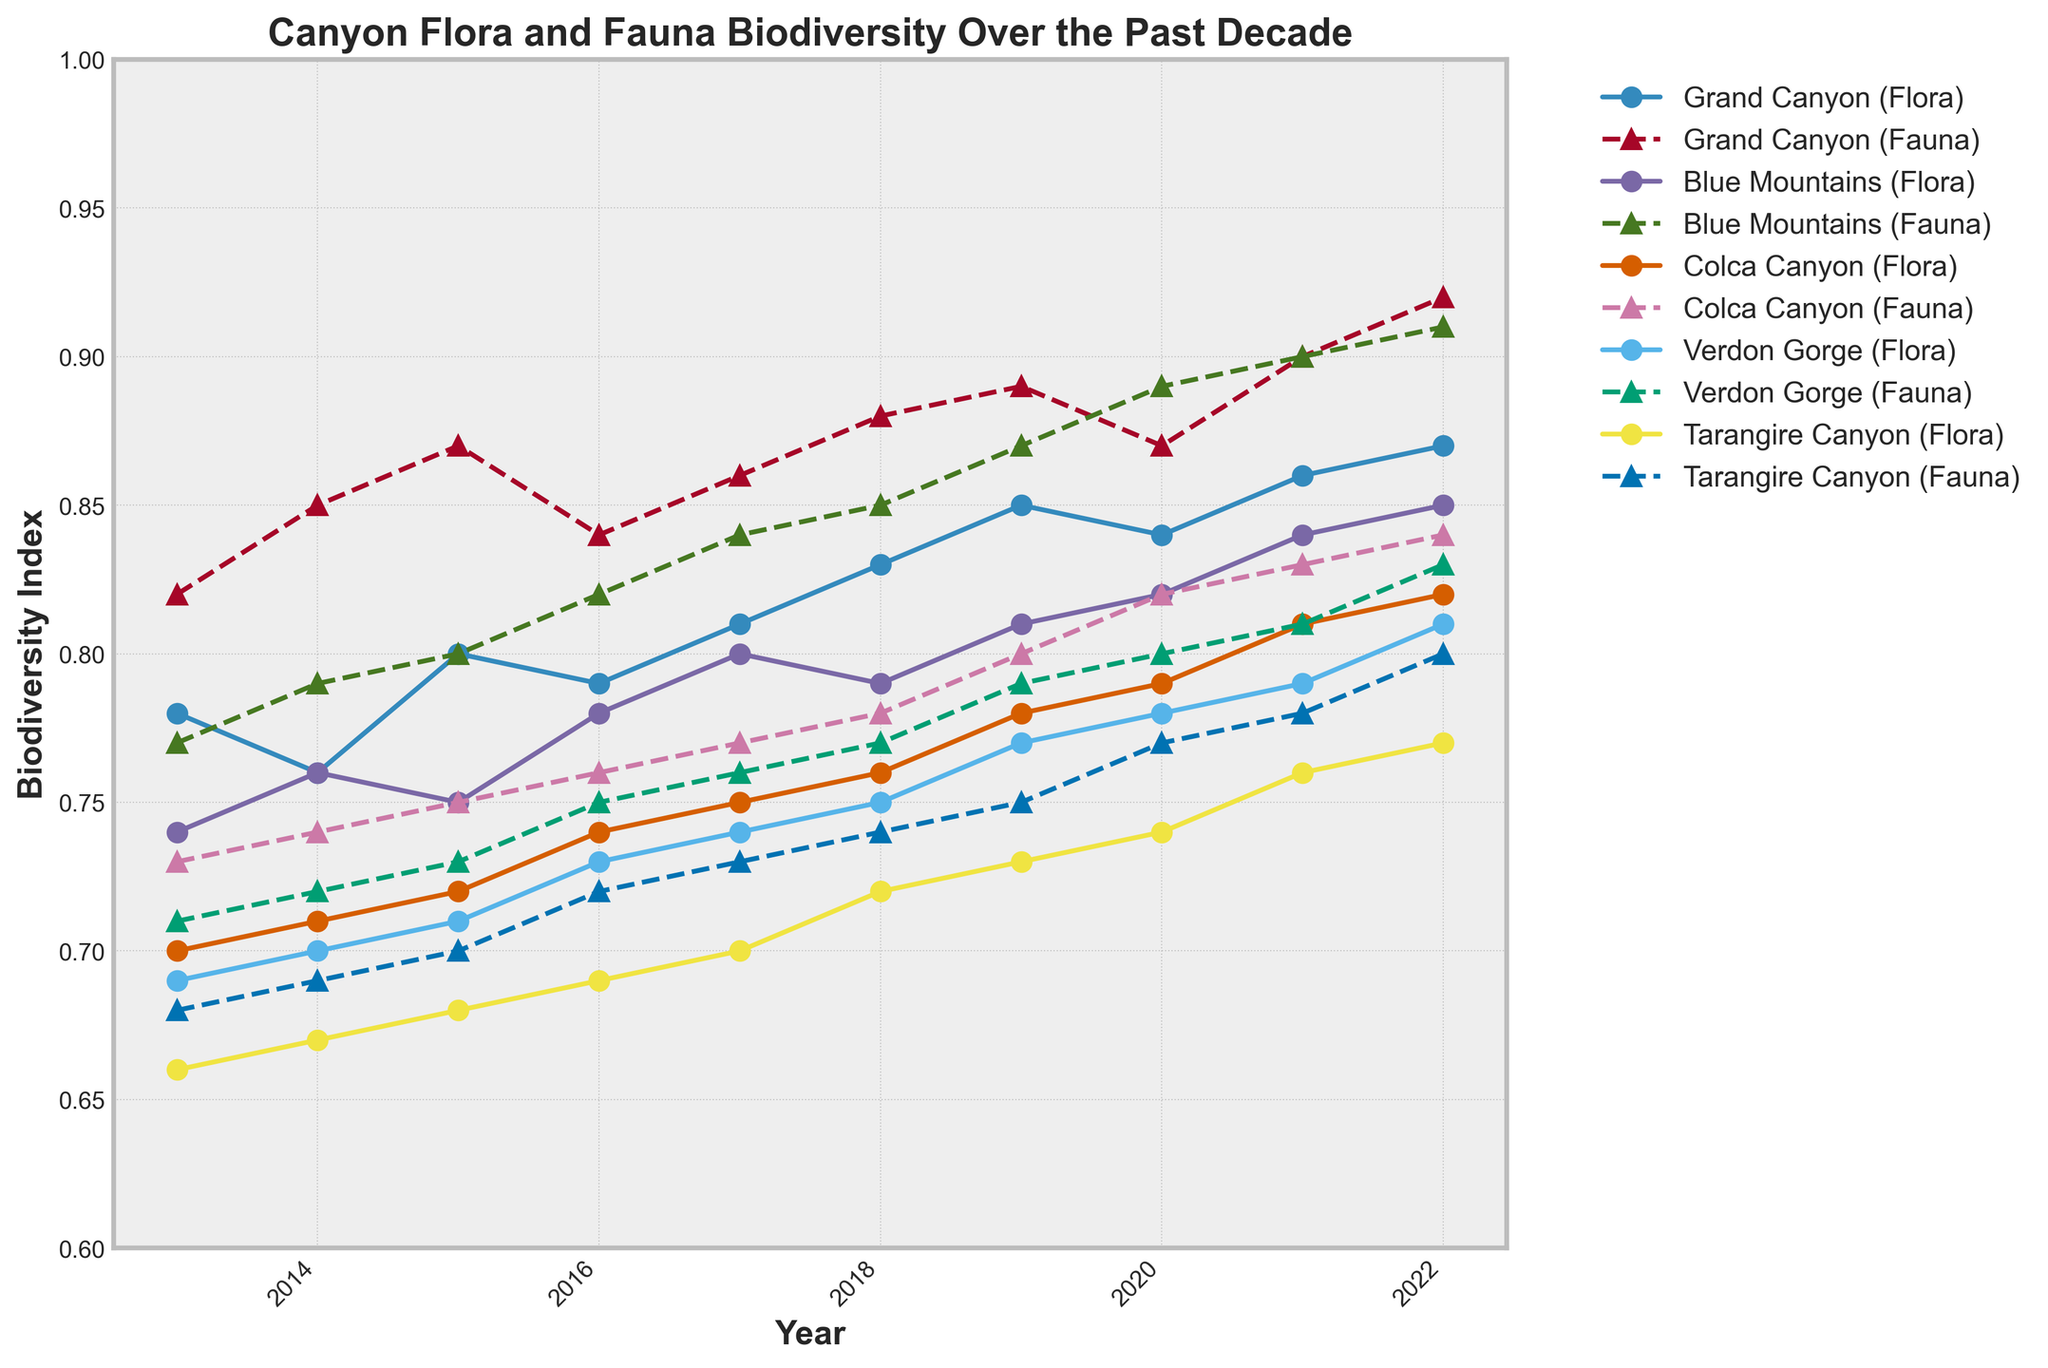How many canyons are represented in the plot? Count the unique entries for the 'Canyon' category in the plot legend or the lines in the plot representing different canyons.
Answer: 5 What is the title of the chart? Look at the title text at the top of the plot.
Answer: Canyon Flora and Fauna Biodiversity Over the Past Decade Which canyon had the highest biodiversity index for fauna in 2022? Identify the line markers for fauna in 2022, then check the highest value among those markers.
Answer: Grand Canyon Which canyon's flora biodiversity has improved the most from 2013 to 2022? Compare the 2013 and 2022 flora values for each canyon, calculate the difference, and find the largest one.
Answer: Verdon Gorge How did the biodiversity index for Blue Mountains' fauna change from 2015 to 2019? Look at the fauna biodiversity index values for Blue Mountains for the mentioned years and calculate the difference.
Answer: Increased from 0.80 to 0.87 (an increase of 0.07) Between which two consecutive years did Tarangire Canyon experience the largest increase in fauna biodiversity? Compare yearly changes in fauna biodiversity index for Tarangire Canyon and find the largest increment.
Answer: 2019 to 2020 For which canyon does the flora biodiversity index show a constant upward trend from 2013 to 2022? Examine the trends in flora biodiversity index over the years for all canyons, checking if each year's value is higher than the last.
Answer: Colca Canyon What was the fauna biodiversity index for Verdon Gorge in 2018? Locate the fauna biodiversity index for Verdon Gorge in the plot for the year 2018.
Answer: 0.77 Which canyon had the lowest starting biodiversity index for flora in 2013? Identify the flora biodiversity index for all canyons in 2013 and find the lowest one.
Answer: Tarangire Canyon How did the biodiversity indices for flora and fauna in Grand Canyon change from 2019 to 2022? Check the plot for Grand Canyon flora and fauna values in 2019 and 2022, then calculate the difference for both.
Answer: Flora increased from 0.85 to 0.87 (0.02 increase) and Fauna increased from 0.89 to 0.92 (0.03 increase) 